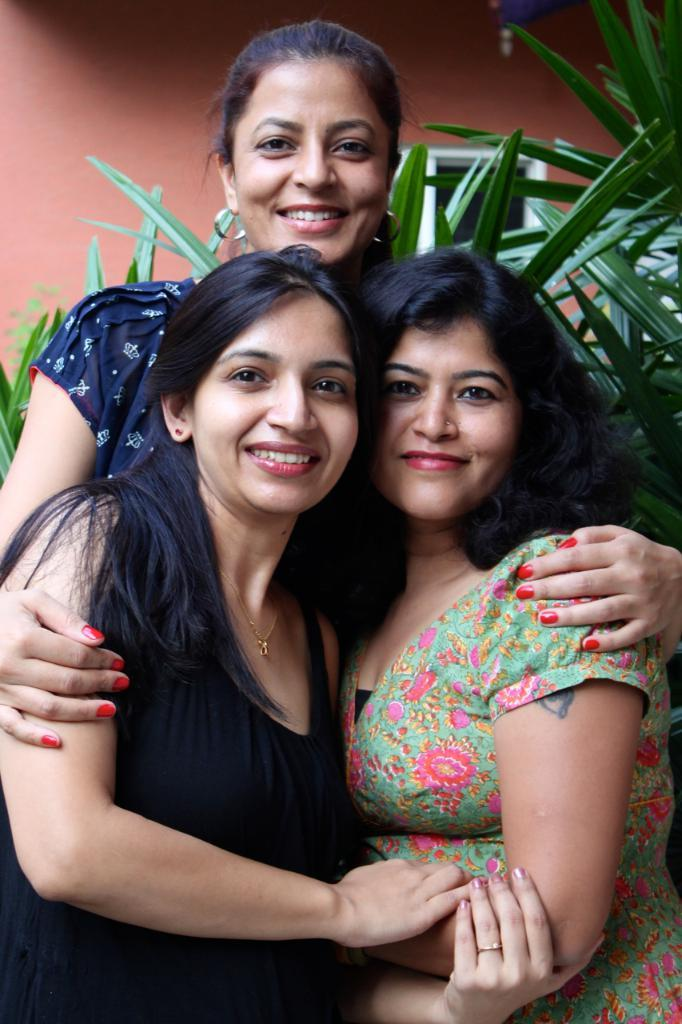How many people are in the center of the image? There are three ladies in the center of the image. What expression do the ladies have? The ladies are smiling. What can be seen in the background of the image? There are plants and a window on the wall in the background of the image. Are the ladies taking a bath together in the image? No, there is no indication of a bath or any water-related activity in the image. 